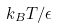Convert formula to latex. <formula><loc_0><loc_0><loc_500><loc_500>k _ { B } T / \epsilon</formula> 